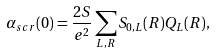<formula> <loc_0><loc_0><loc_500><loc_500>\alpha _ { s c r } ( 0 ) = \frac { 2 S } { e ^ { 2 } } \sum _ { L , R } S _ { 0 , L } ( { R } ) Q _ { L } ( { R } ) ,</formula> 